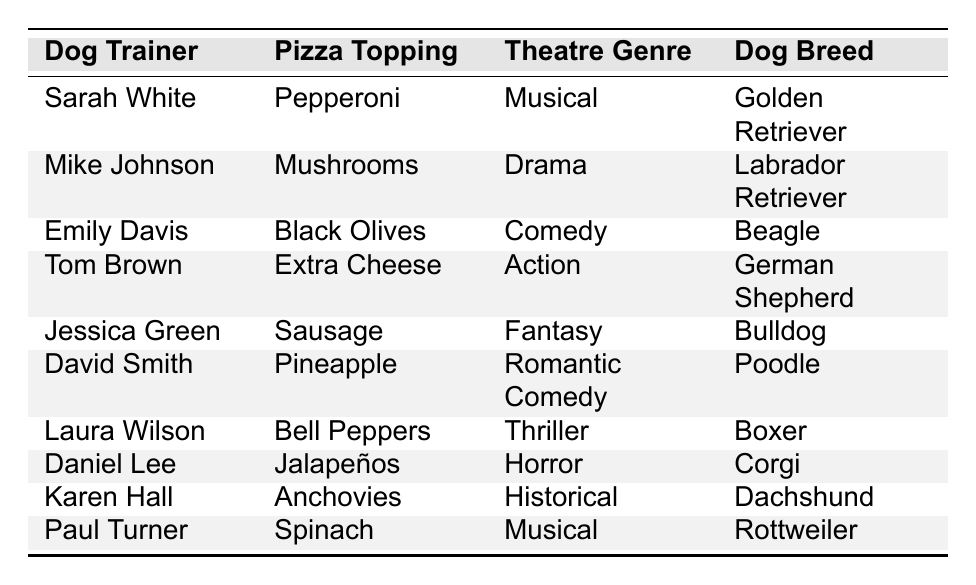What pizza topping does Sarah White prefer? From the table, we locate Sarah White in the first row and see that her preferred topping is listed as Pepperoni.
Answer: Pepperoni Which two pizza toppings are preferred by dog trainers who enjoy Musical theatre? We check the table for trainers with Musical as their favorite theatre genre. Sarah White prefers Pepperoni, and Paul Turner prefers Spinach.
Answer: Pepperoni and Spinach How many dog trainers prefer Sausage as their pizza topping? We look at the table and find that only Jessica Green has Sausage listed as her preferred topping. Count shows one trainer.
Answer: 1 Which dog breed is most commonly associated with the pizza topping Extra Cheese? Tom Brown prefers Extra Cheese as his topping, and he has a German Shepherd. There are no other entries for Extra Cheese, so German Shepherd is the sole breed associated with that topping.
Answer: German Shepherd Is there any dog trainer whose favorite theatre genre is Comedy? In the table, Emily Davis is listed with Comedy as her favorite theatre genre, indicating that the statement is true.
Answer: Yes What pizza toppings do dog trainers who own a Beagle prefer? We search for any dog trainer associated with the Beagle breed and find that Emily Davis prefers Black Olives as her topping.
Answer: Black Olives Which dog trainer prefers Pineapple and what is their dog breed? David Smith is listed in the table with Pineapple as his preferred topping, and he has a Poodle.
Answer: David Smith, Poodle Are there any dog trainers whose favorite theatre genre is Thriller or Horror? Laura Wilson has Thriller and Daniel Lee has Horror listed as their favorite genres. Thus, both genres are represented by trainers.
Answer: Yes What is the average number of unique pizza toppings mentioned in the table? We can count the unique toppings: Pepperoni, Mushrooms, Black Olives, Extra Cheese, Sausage, Pineapple, Bell Peppers, Jalapeños, Anchovies, and Spinach. This totals 10 unique toppings. Thus, the average is also 10 since there's no grouping.
Answer: 10 How many trainers prefer vegetarian options (no meat)? The vegetarian toppings in the list are Mushrooms, Black Olives, Bell Peppers, Pineapple, Spinach, and Jalapeños. By checking the table, we find that 5 trainers (Mike, Emily, Laura, David, and Paul) prefer these options.
Answer: 5 